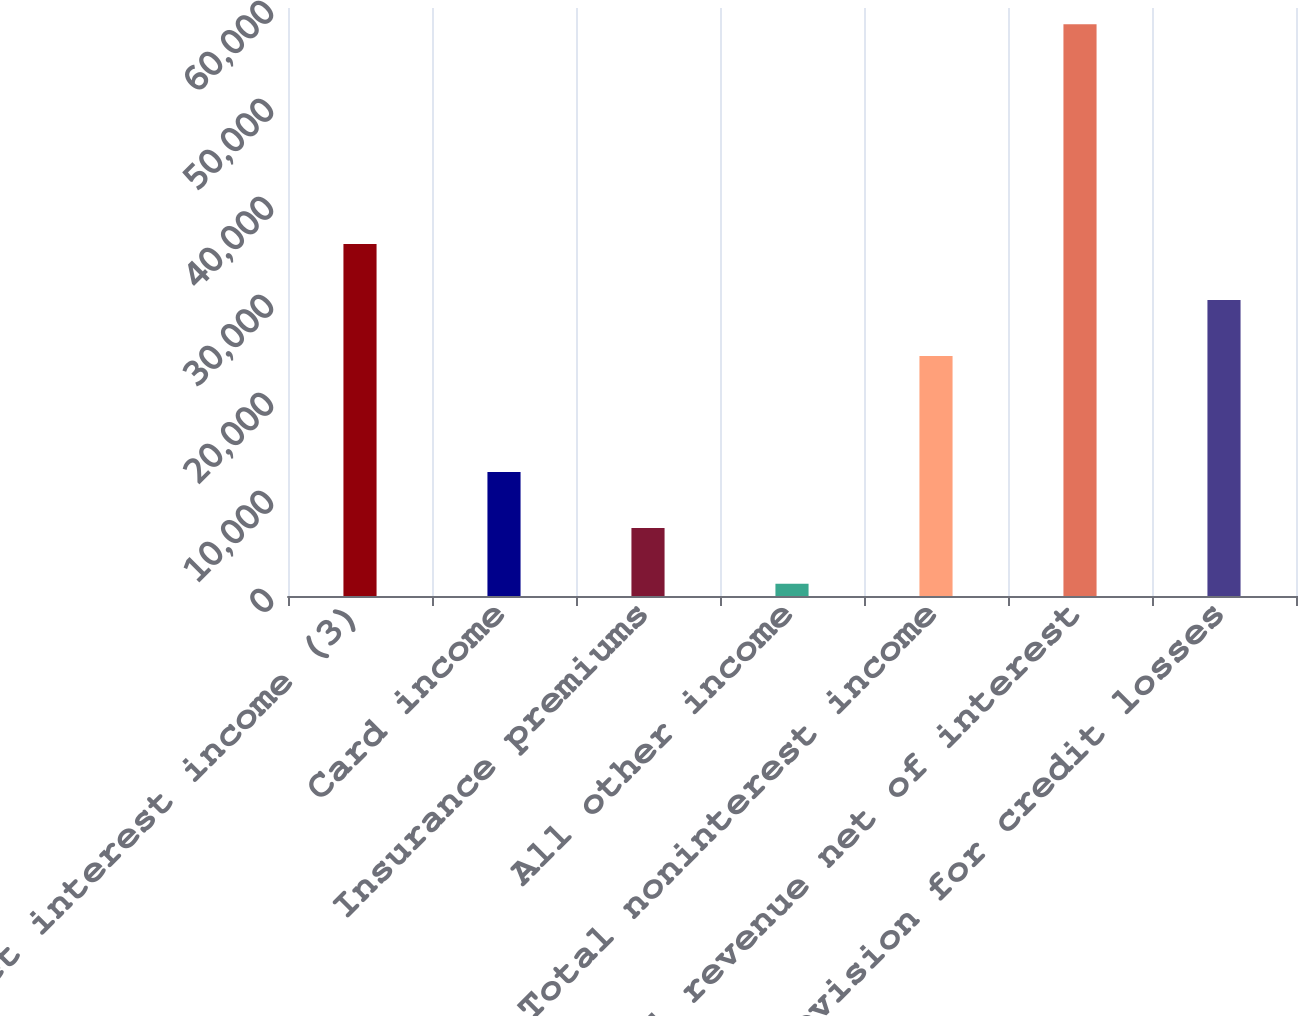<chart> <loc_0><loc_0><loc_500><loc_500><bar_chart><fcel>Net interest income (3)<fcel>Card income<fcel>Insurance premiums<fcel>All other income<fcel>Total noninterest income<fcel>Total revenue net of interest<fcel>Provision for credit losses<nl><fcel>35914<fcel>12660<fcel>6949.5<fcel>1239<fcel>24493<fcel>58344<fcel>30203.5<nl></chart> 